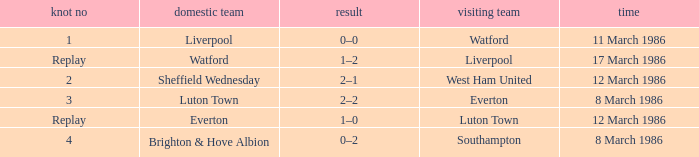What was the tie resulting from Sheffield Wednesday's game? 2.0. 